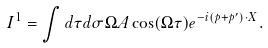Convert formula to latex. <formula><loc_0><loc_0><loc_500><loc_500>I ^ { 1 } = \int d \tau d \sigma \Omega A \cos ( \Omega \tau ) e ^ { - i ( p + p ^ { \prime } ) \cdot X } .</formula> 